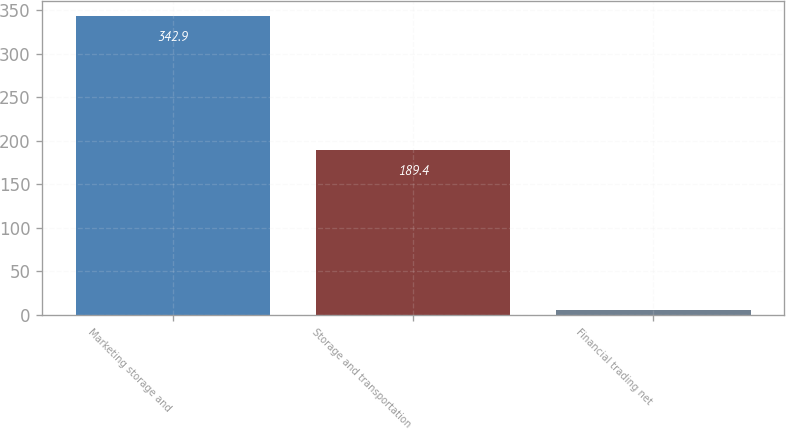Convert chart to OTSL. <chart><loc_0><loc_0><loc_500><loc_500><bar_chart><fcel>Marketing storage and<fcel>Storage and transportation<fcel>Financial trading net<nl><fcel>342.9<fcel>189.4<fcel>6.2<nl></chart> 